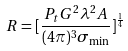<formula> <loc_0><loc_0><loc_500><loc_500>R = [ \frac { P _ { t } G ^ { 2 } \lambda ^ { 2 } A } { ( 4 \pi ) ^ { 3 } \sigma _ { \min } } ] ^ { \frac { 1 } { 4 } }</formula> 